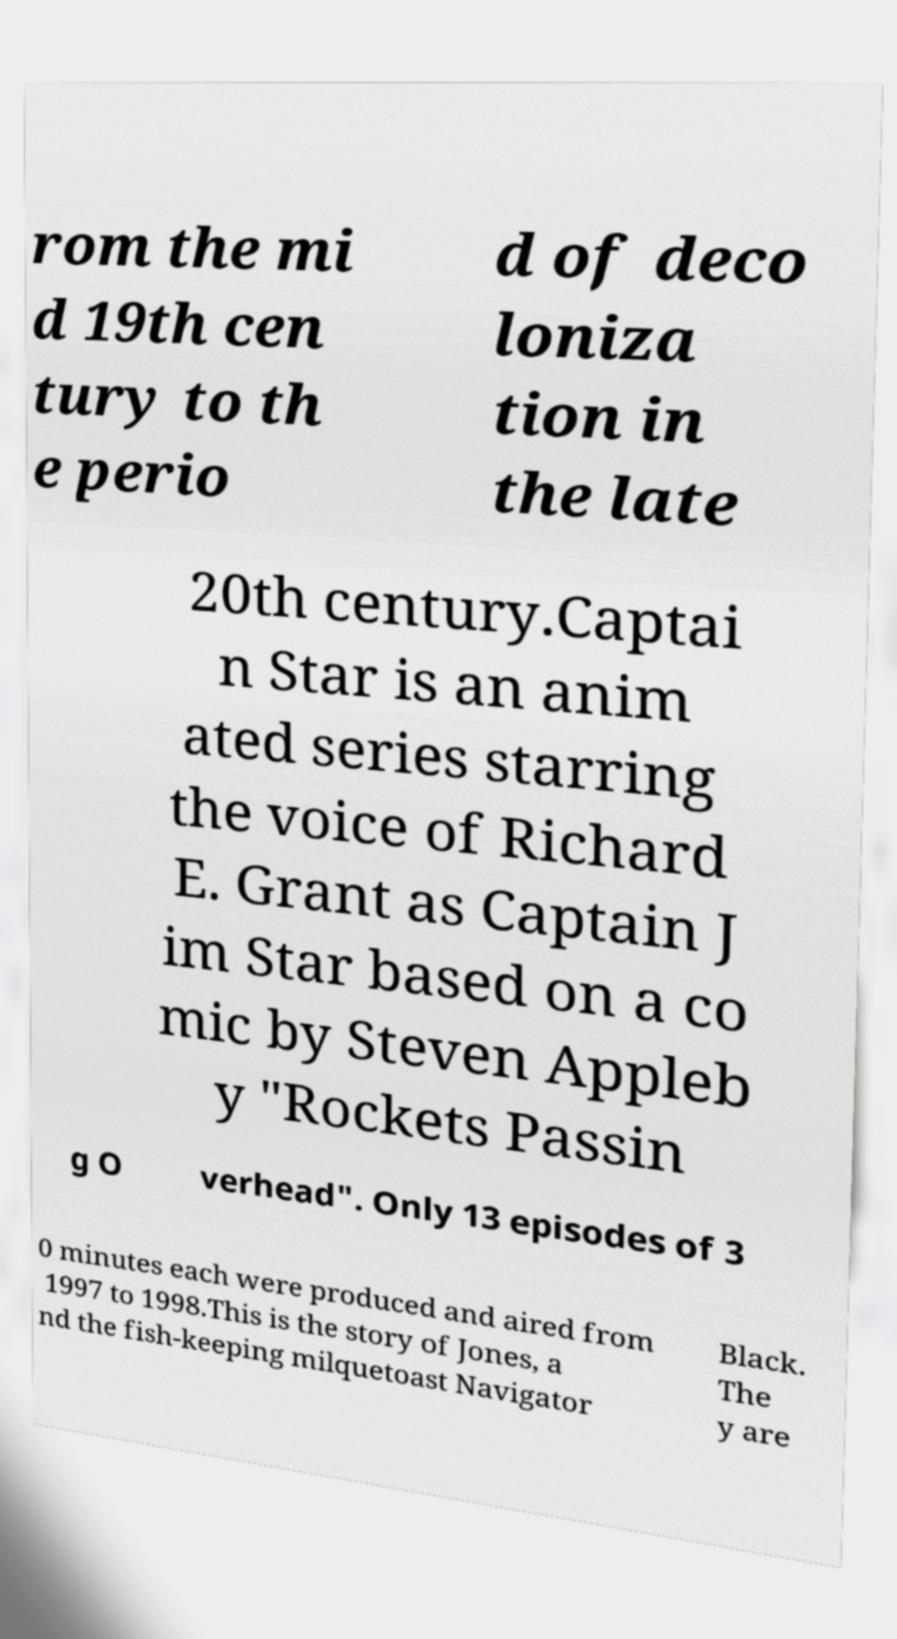Please identify and transcribe the text found in this image. rom the mi d 19th cen tury to th e perio d of deco loniza tion in the late 20th century.Captai n Star is an anim ated series starring the voice of Richard E. Grant as Captain J im Star based on a co mic by Steven Appleb y "Rockets Passin g O verhead". Only 13 episodes of 3 0 minutes each were produced and aired from 1997 to 1998.This is the story of Jones, a nd the fish-keeping milquetoast Navigator Black. The y are 